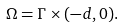<formula> <loc_0><loc_0><loc_500><loc_500>\Omega = \Gamma \times ( - d , 0 ) .</formula> 